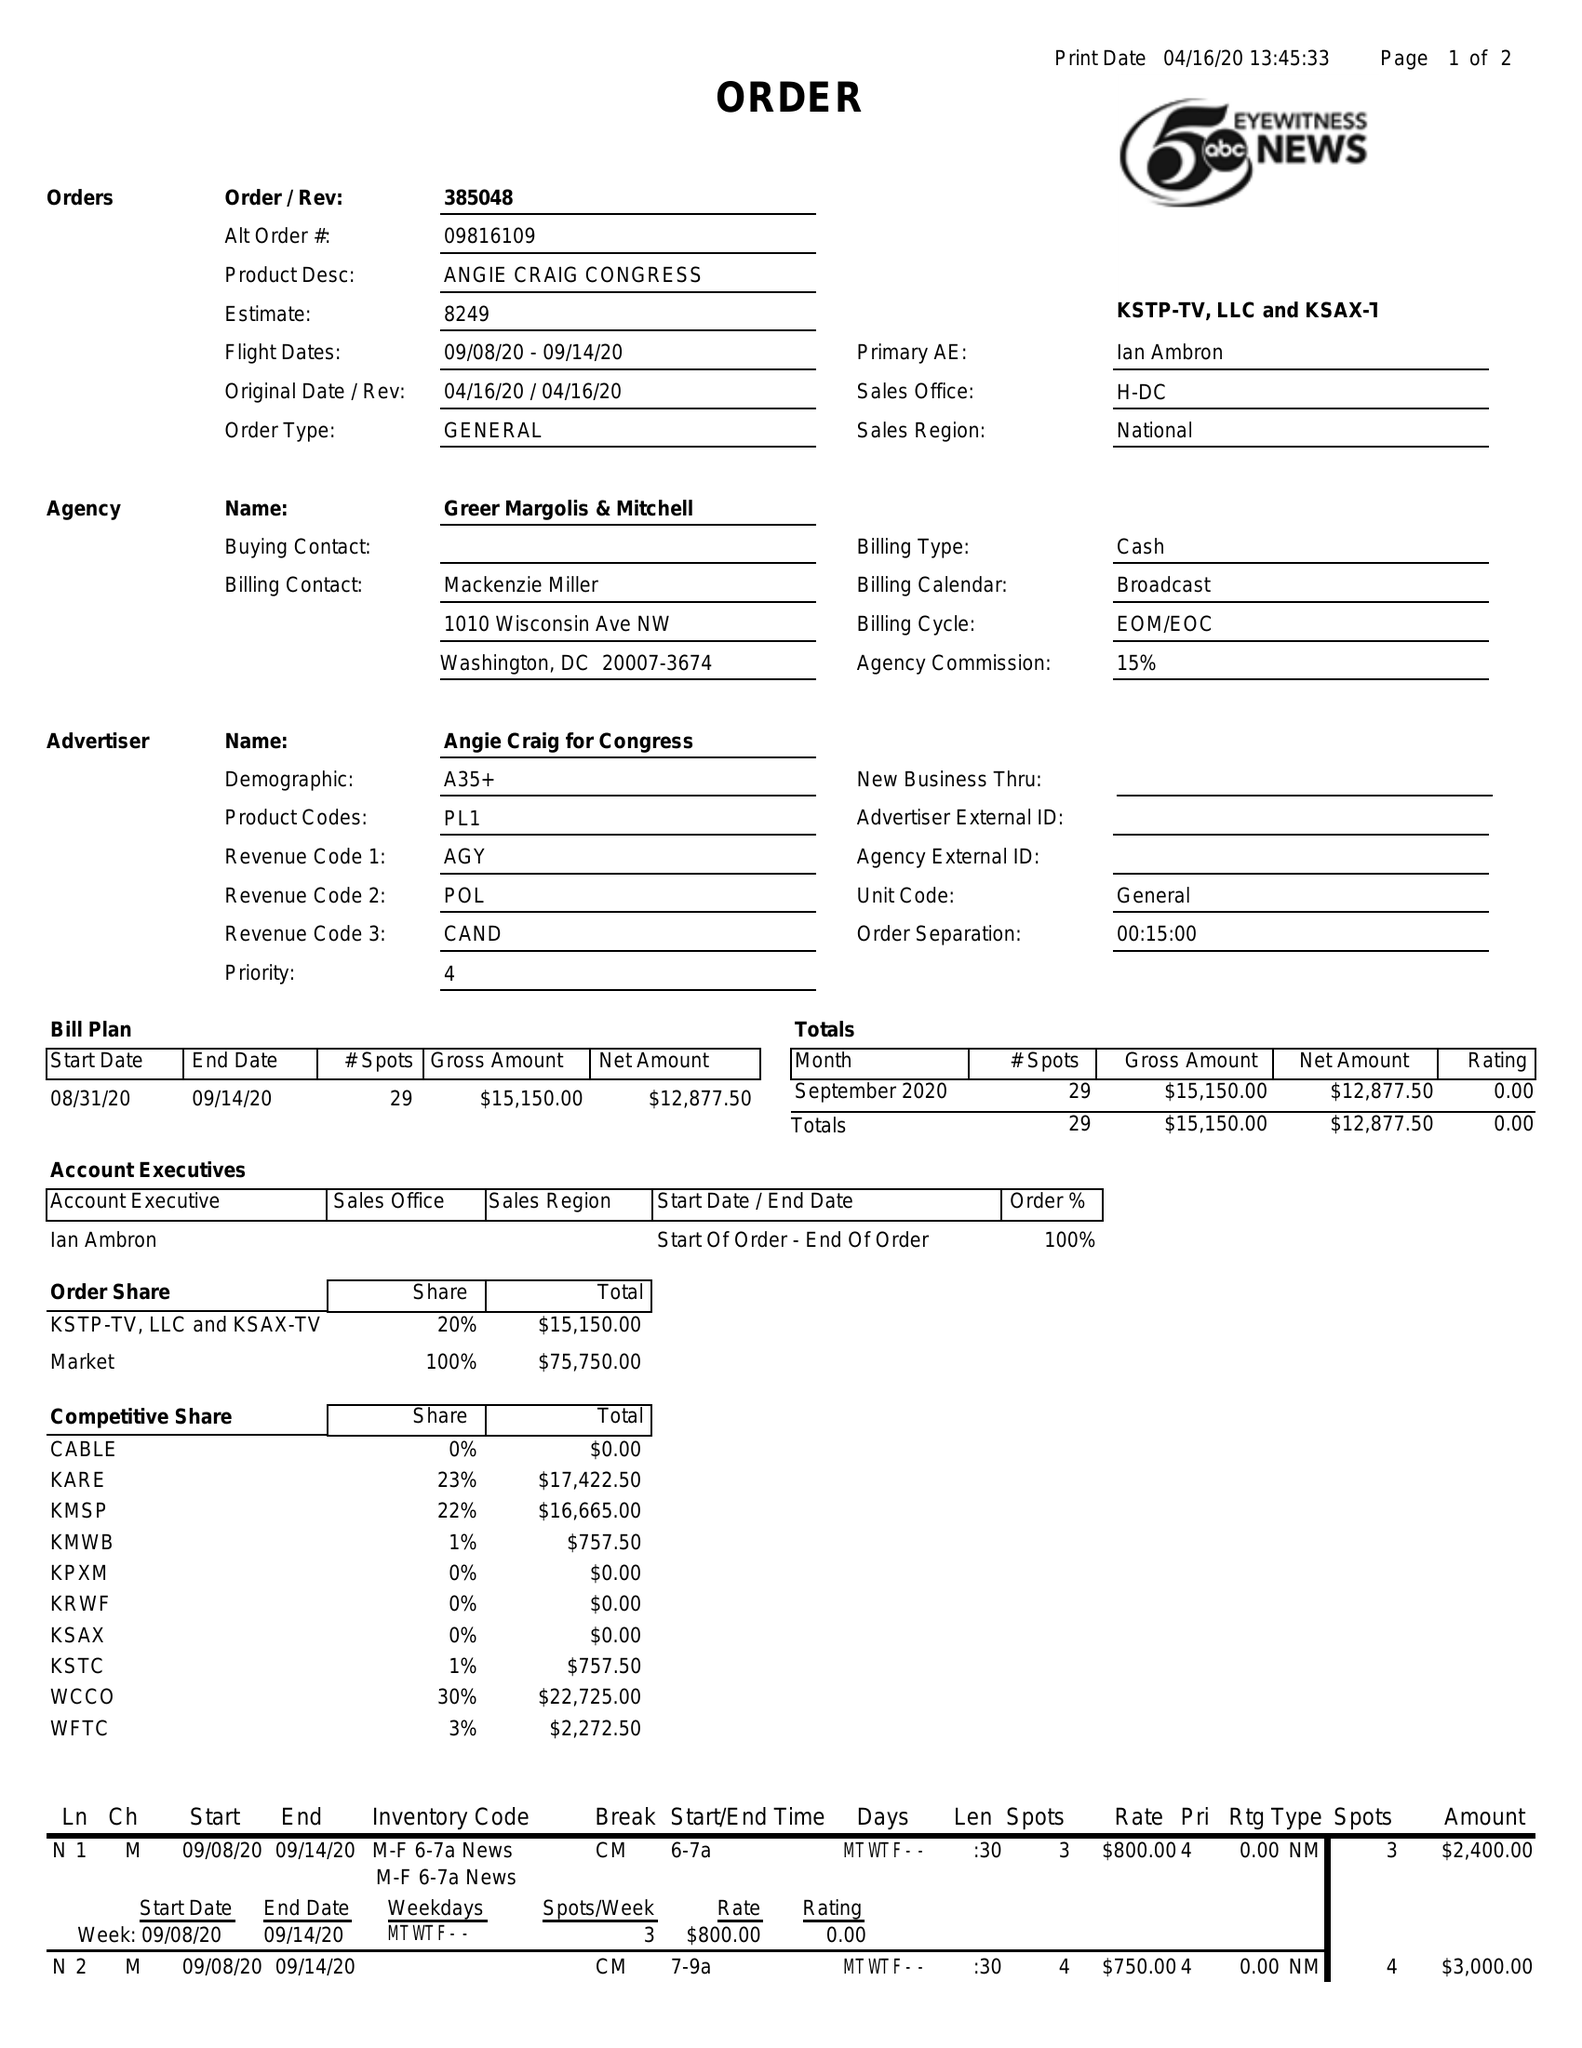What is the value for the gross_amount?
Answer the question using a single word or phrase. 15150.00 